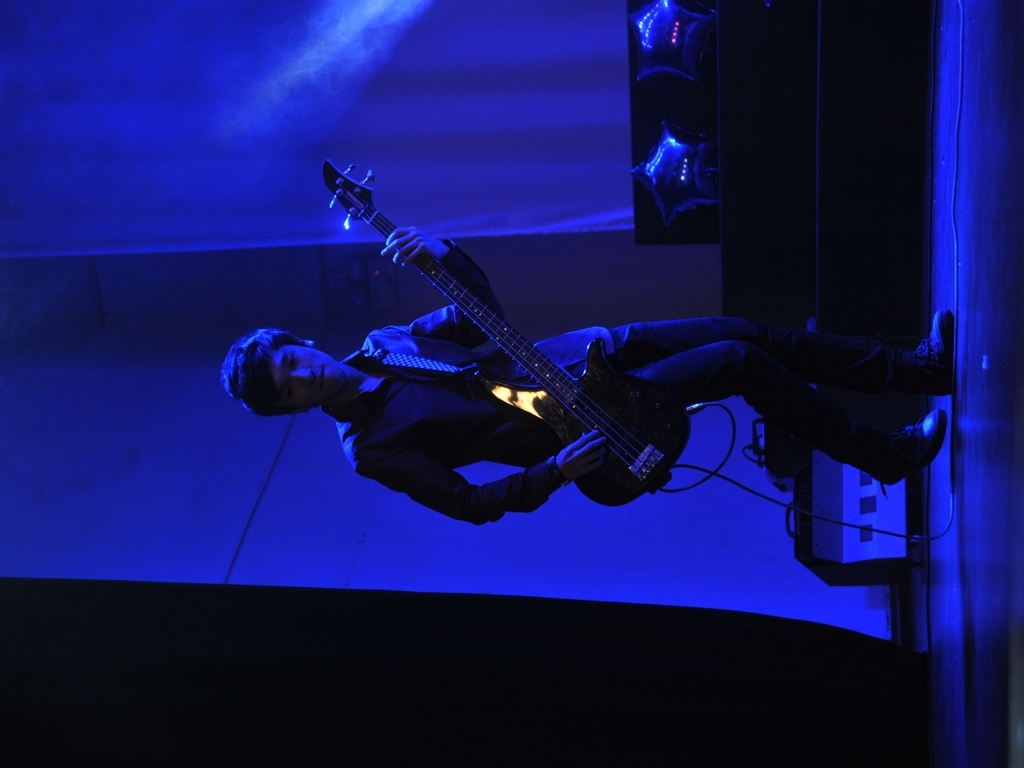What genre of music might this bassist be performing? Based on the dark attire and the moody lighting, which is often associated with more intense music performances, he could likely be playing something within the rock, indie, or alternative genres. These genres frequently feature such atmospheric stage setups to complement the energy and emotion of the music. 